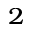Convert formula to latex. <formula><loc_0><loc_0><loc_500><loc_500>_ { 2 }</formula> 